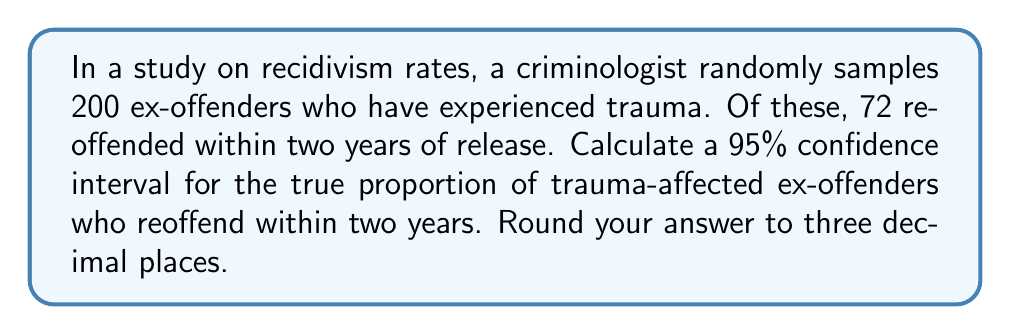Help me with this question. To estimate the population parameter (true proportion of trauma-affected ex-offenders who reoffend) using sample data, we'll calculate a confidence interval.

Given:
- Sample size: $n = 200$
- Number of ex-offenders who reoffended: $x = 72$
- Confidence level: 95% (z-score = 1.96)

Step 1: Calculate the sample proportion ($\hat{p}$)
$$\hat{p} = \frac{x}{n} = \frac{72}{200} = 0.36$$

Step 2: Calculate the standard error (SE)
$$SE = \sqrt{\frac{\hat{p}(1-\hat{p})}{n}} = \sqrt{\frac{0.36(1-0.36)}{200}} = 0.0339$$

Step 3: Determine the z-score for 95% confidence level
For 95% confidence, z = 1.96

Step 4: Calculate the margin of error (ME)
$$ME = z \times SE = 1.96 \times 0.0339 = 0.0664$$

Step 5: Calculate the confidence interval
Lower bound: $\hat{p} - ME = 0.36 - 0.0664 = 0.2936$
Upper bound: $\hat{p} + ME = 0.36 + 0.0664 = 0.4264$

Therefore, the 95% confidence interval is (0.294, 0.426) when rounded to three decimal places.
Answer: (0.294, 0.426) 